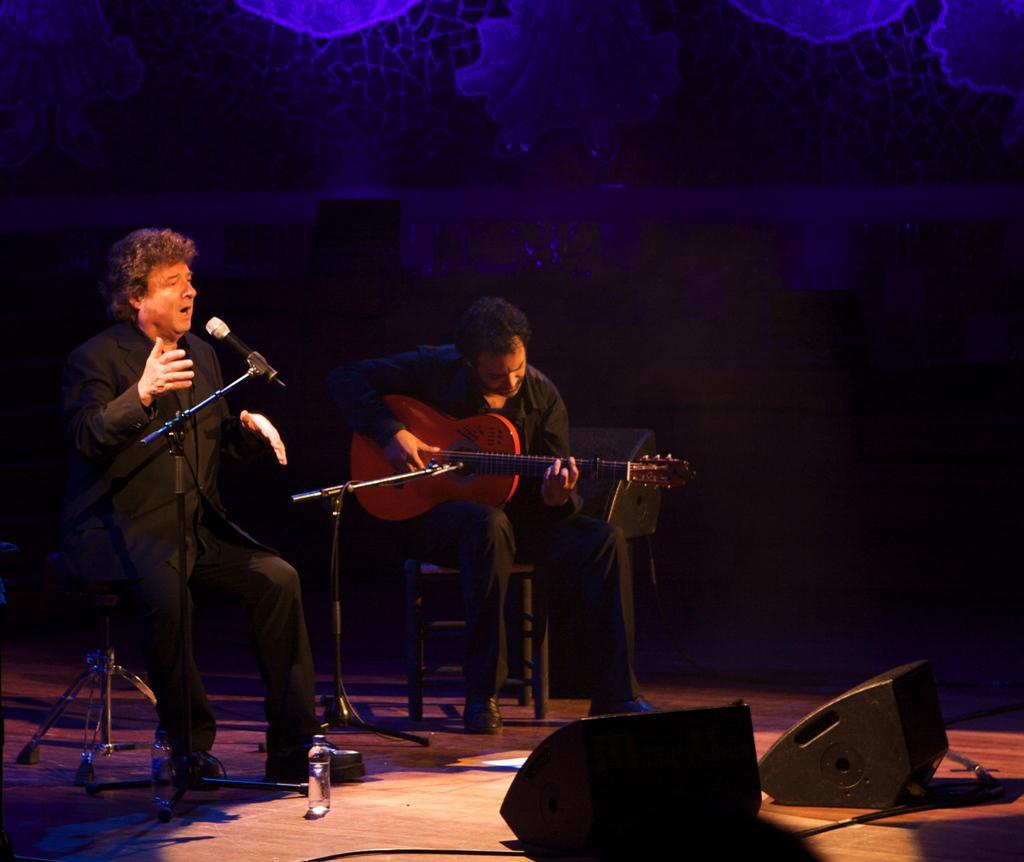Describe this image in one or two sentences. Here we can see 2 persons wearing black colored dress, the left person is singing and the other playing guitar. Both of them are sitting. In front of the left person we have a microphone and hear the bottom part looks like stage. On it we have water bottles present, sound boxes present. In the background it seems like decoration set. Overall it looks like musical concert. 